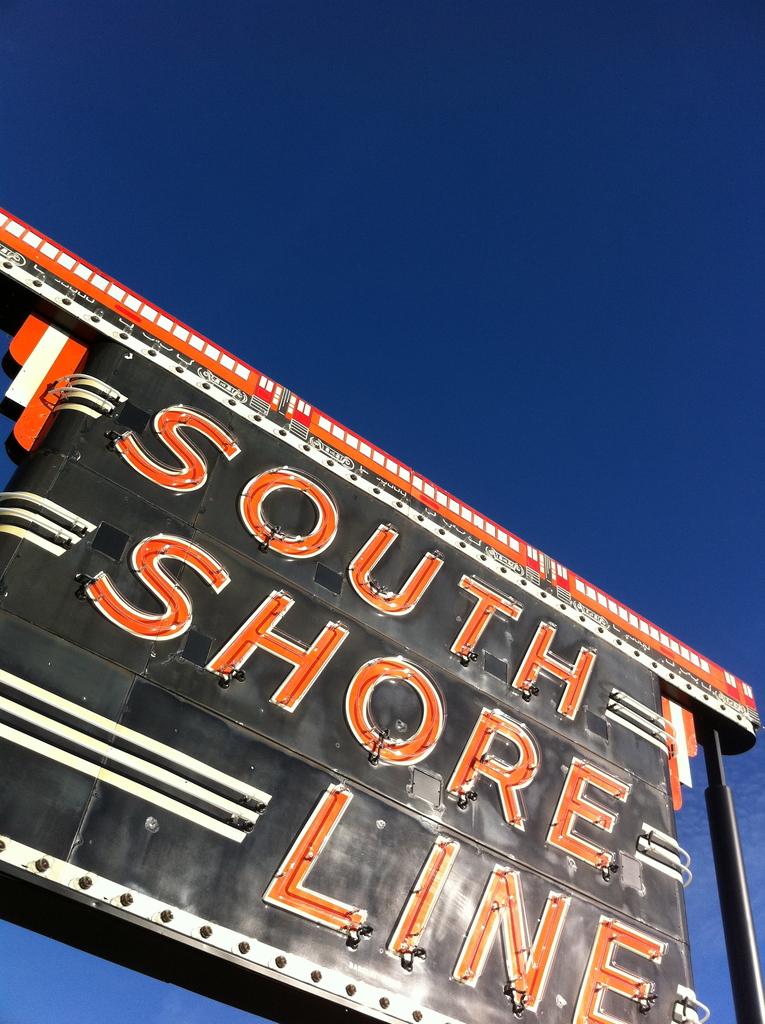What line is mentioned on the sign?
Your answer should be compact. South shore line. 